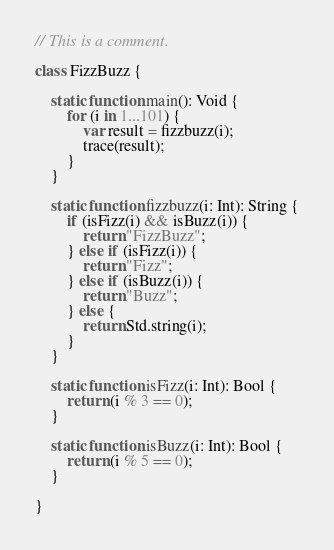Convert code to text. <code><loc_0><loc_0><loc_500><loc_500><_Haxe_>// This is a comment.

class FizzBuzz {

    static function main(): Void {
        for (i in 1...101) {
            var result = fizzbuzz(i);
            trace(result);
        }
    }

    static function fizzbuzz(i: Int): String {
        if (isFizz(i) && isBuzz(i)) {
            return "FizzBuzz";
        } else if (isFizz(i)) {
            return "Fizz";
        } else if (isBuzz(i)) {
            return "Buzz";
        } else {
            return Std.string(i);
        }
    }

    static function isFizz(i: Int): Bool {
        return (i % 3 == 0);
    }

    static function isBuzz(i: Int): Bool {
        return (i % 5 == 0);
    }

}

</code> 